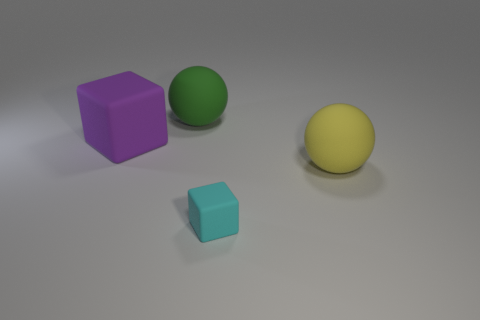What is the shape of the purple matte thing that is the same size as the green ball?
Keep it short and to the point. Cube. What material is the object that is in front of the big green sphere and behind the large yellow ball?
Give a very brief answer. Rubber. Is the tiny cube made of the same material as the big ball right of the large green sphere?
Provide a short and direct response. Yes. Is the number of rubber cubes that are behind the cyan rubber thing greater than the number of things that are left of the big purple rubber cube?
Your response must be concise. Yes. The tiny cyan rubber object has what shape?
Ensure brevity in your answer.  Cube. Do the ball on the left side of the yellow ball and the block left of the cyan matte cube have the same material?
Your answer should be very brief. Yes. There is a big object right of the tiny cyan rubber thing; what shape is it?
Your response must be concise. Sphere. What size is the green matte thing that is the same shape as the large yellow thing?
Your answer should be very brief. Large. Are there any matte blocks to the right of the sphere on the left side of the yellow object?
Offer a terse response. Yes. There is another rubber thing that is the same shape as the small matte thing; what is its color?
Offer a terse response. Purple. 